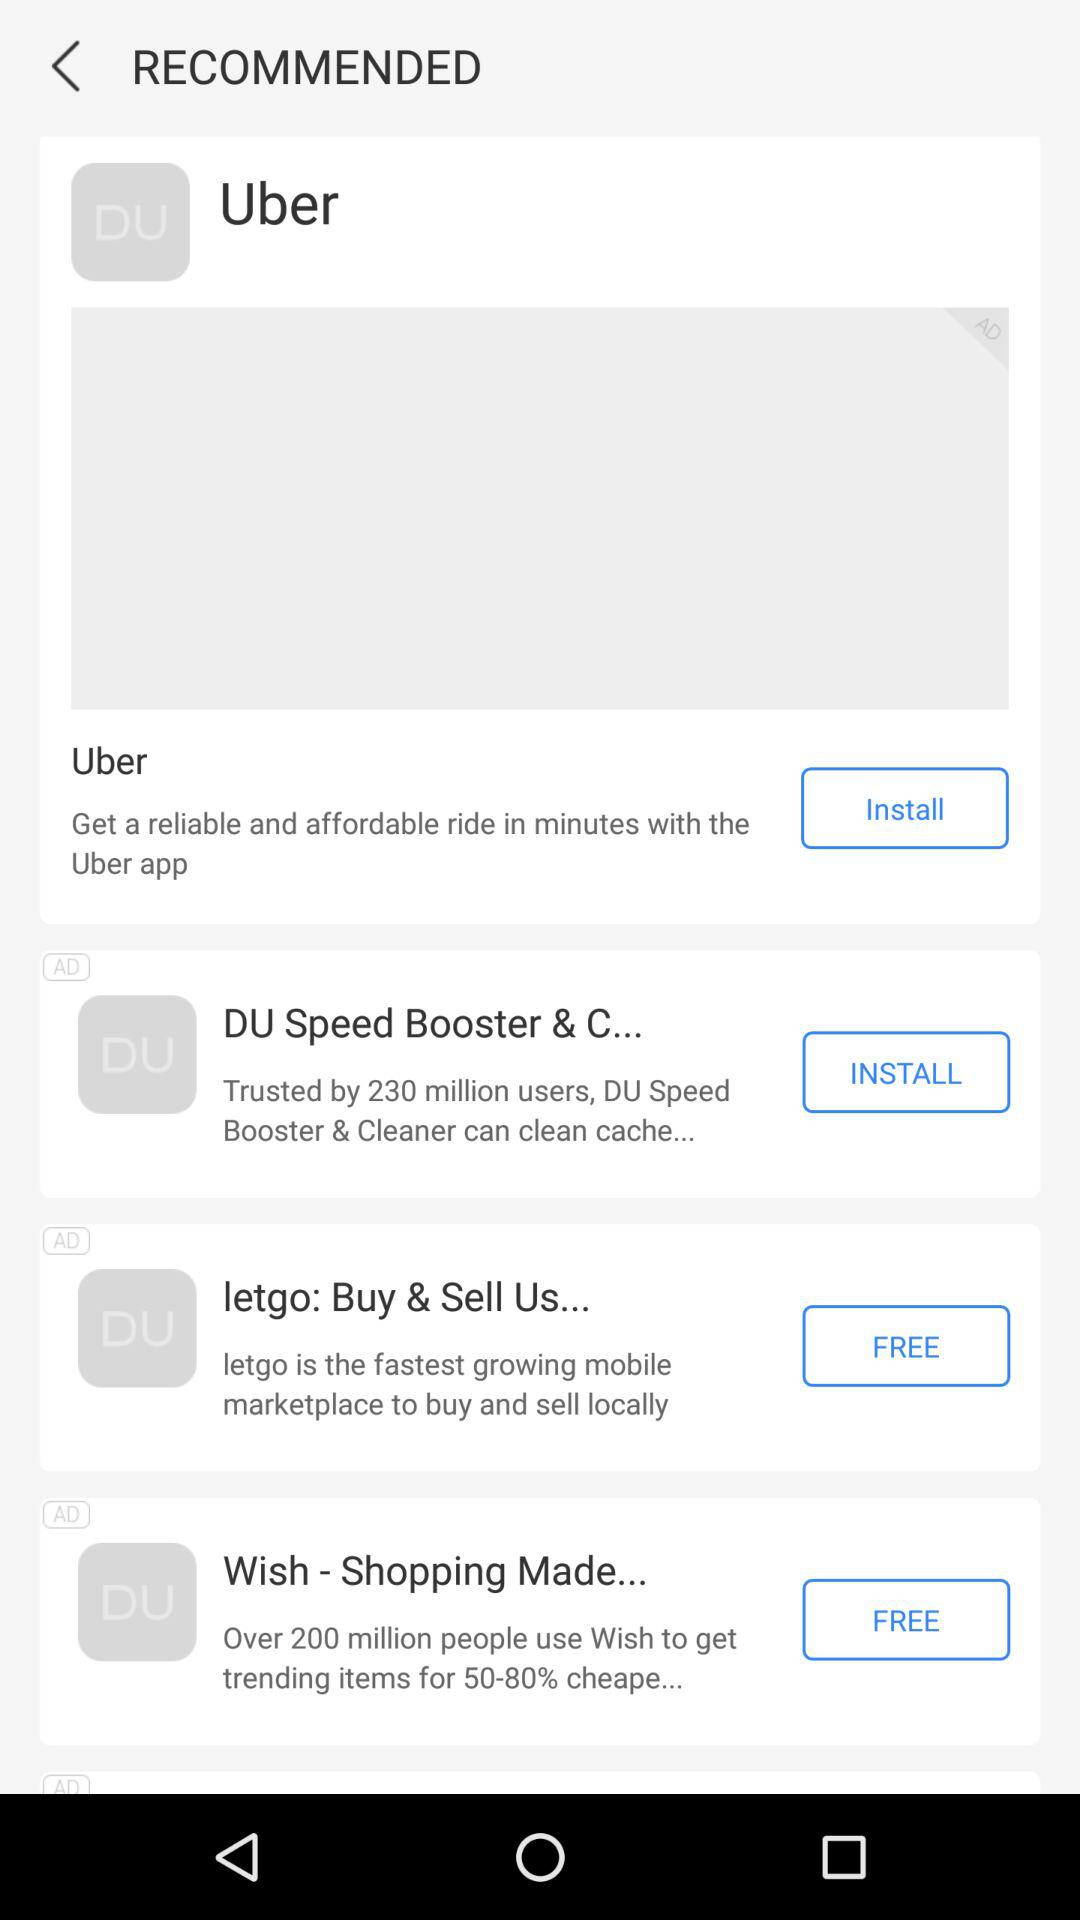What applications are free to install? The applications that are free to install are "letgo: Buy & Sell Us..." and "Wish - Shopping Made...". 